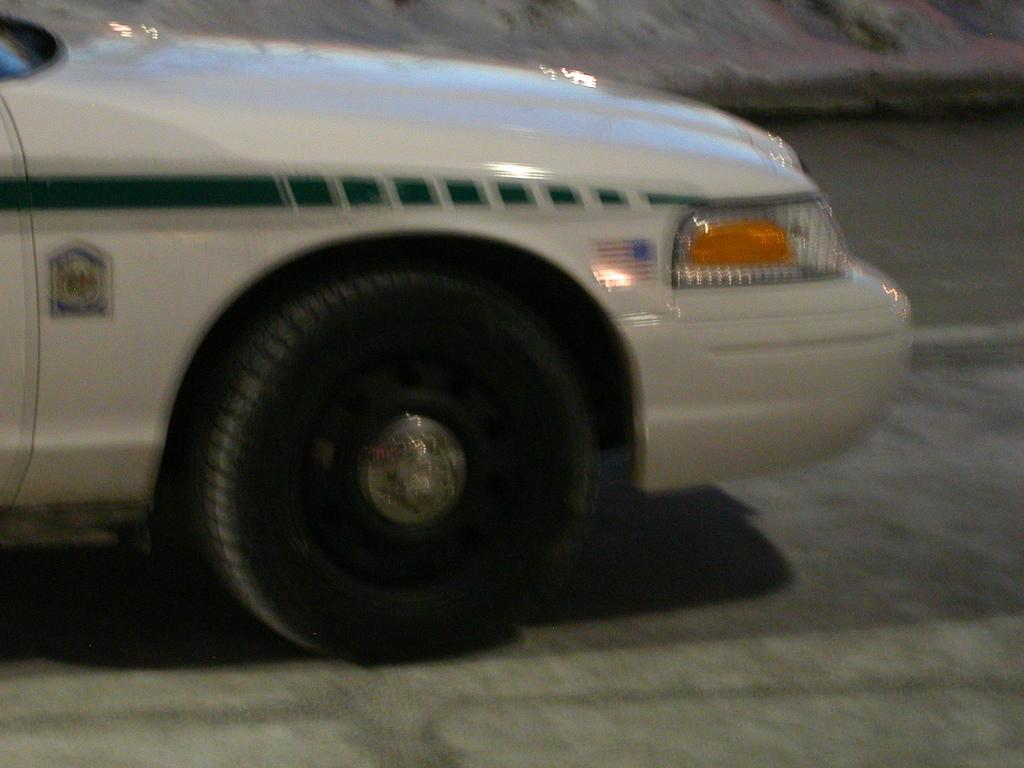What type of image is being shown? The image is a zoomed-in picture. What can be seen in the zoomed-in picture? There is a white color car in the image. How many fifths of the car are visible in the image? The concept of "fifths" does not apply to the visibility of the car in the image, as it is a solid object and not divided into parts. 